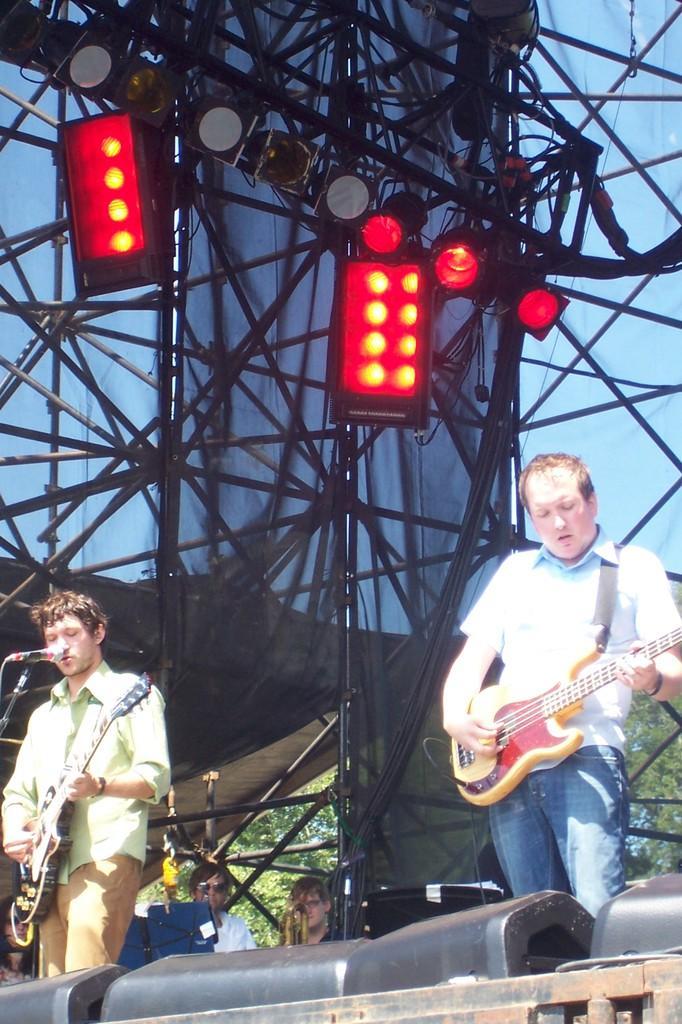Please provide a concise description of this image. There are two mans standing on a stage playing a guitar behind them there are red lights focusing on them from top. 